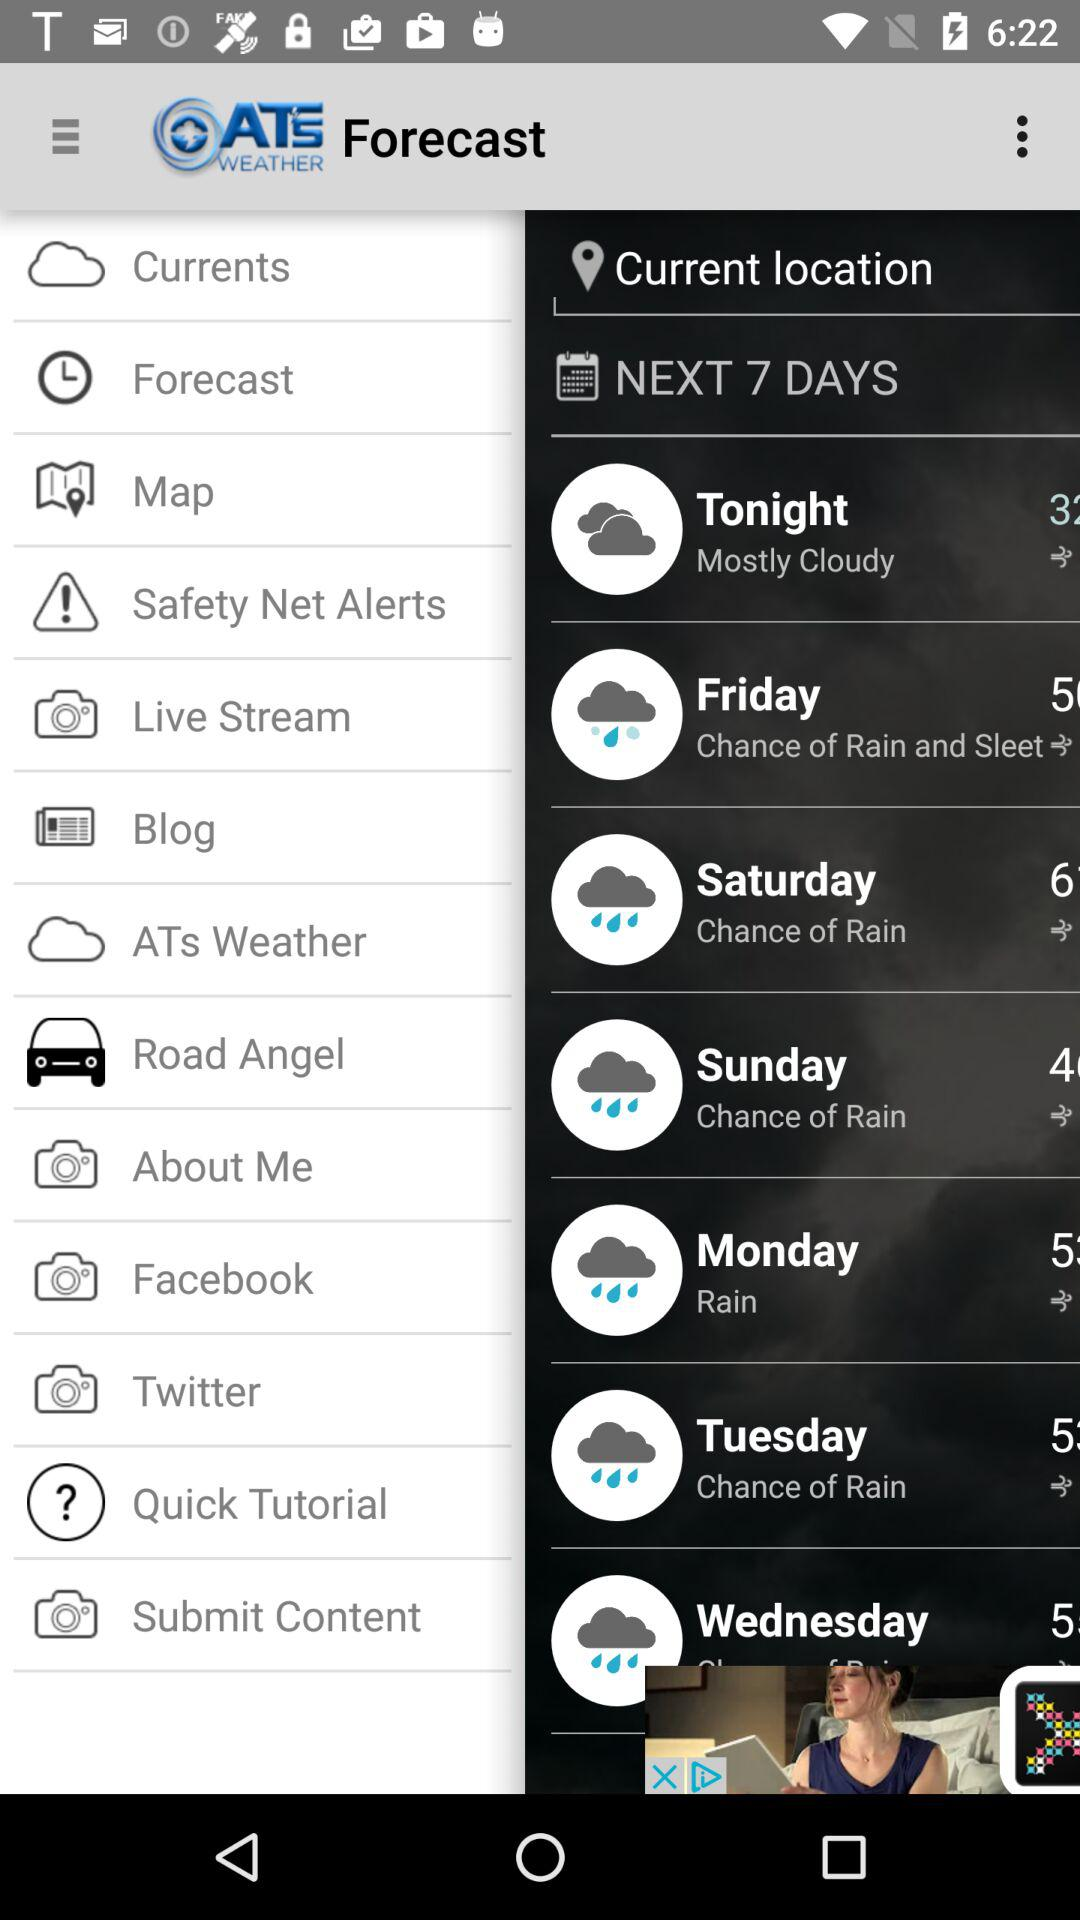What is temperature at tonight?
When the provided information is insufficient, respond with <no answer>. <no answer> 